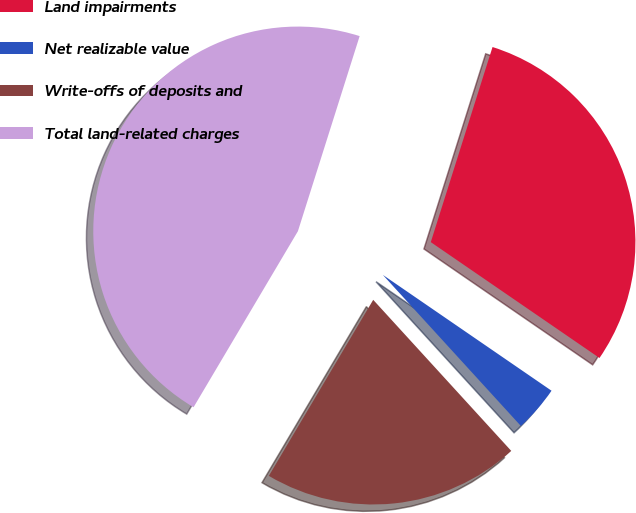Convert chart. <chart><loc_0><loc_0><loc_500><loc_500><pie_chart><fcel>Land impairments<fcel>Net realizable value<fcel>Write-offs of deposits and<fcel>Total land-related charges<nl><fcel>29.7%<fcel>3.64%<fcel>20.3%<fcel>46.36%<nl></chart> 